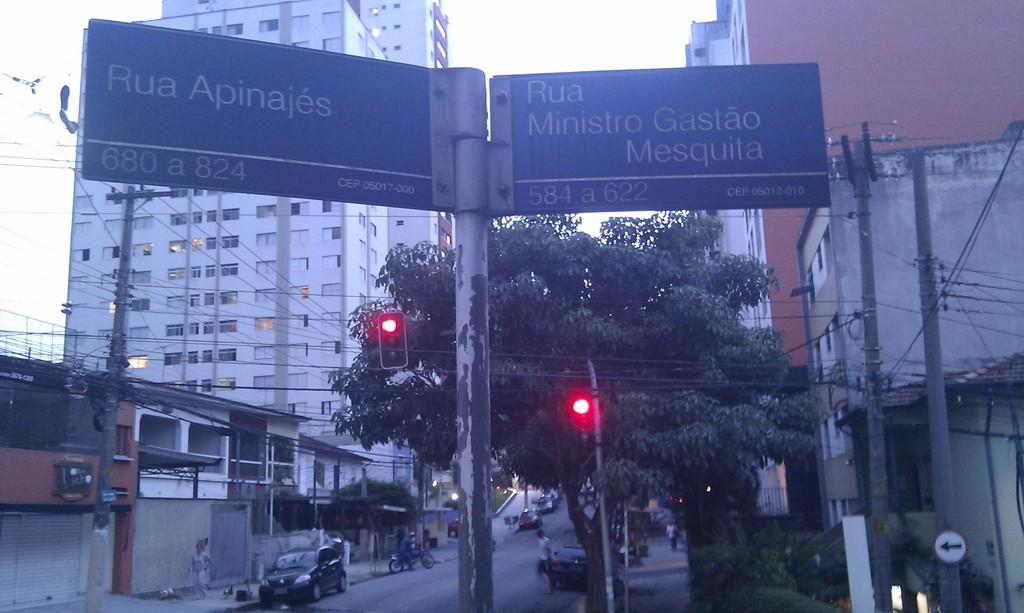Where does the left sign point to?
Your answer should be very brief. Rua apinajes. Where does the right sign point to?
Offer a very short reply. Rua ministro gastao mesquita. 